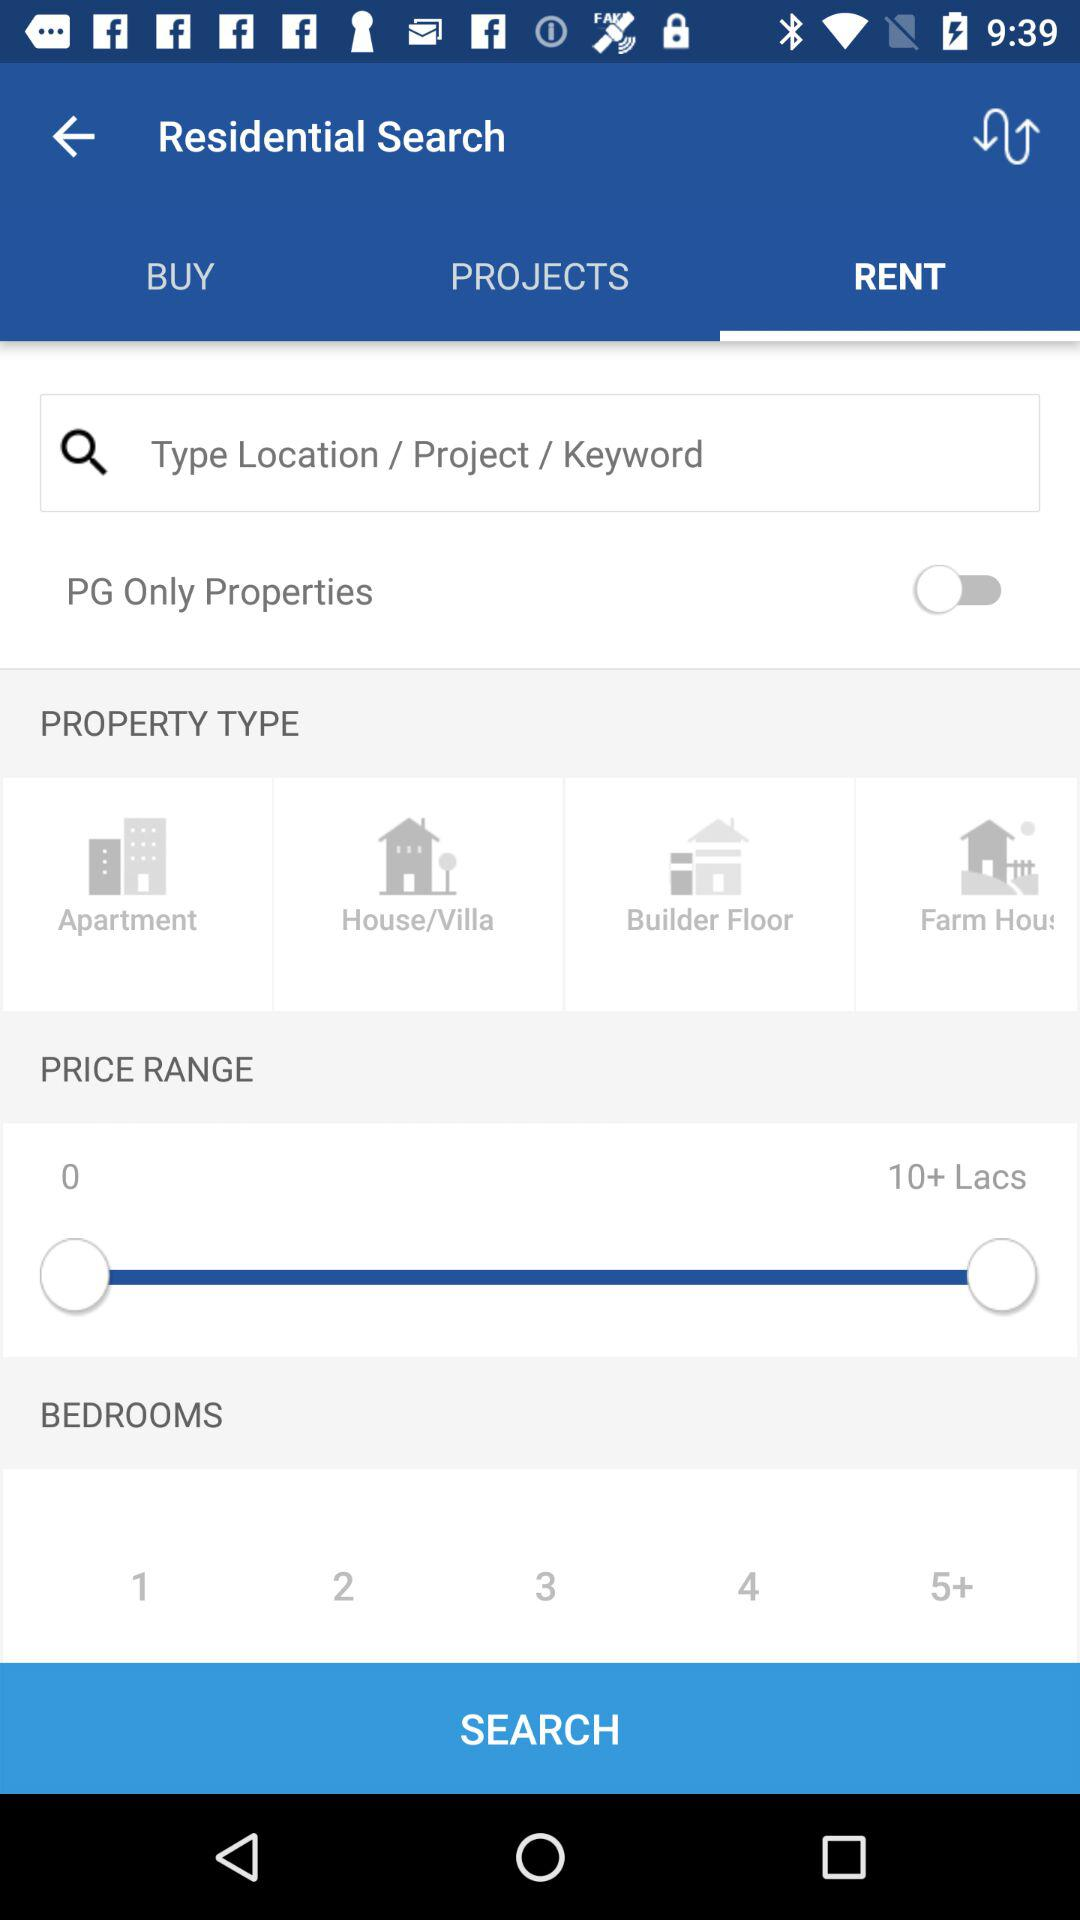What is the range of the price chosen for the property? The price range is 0-10+ Lacs. 